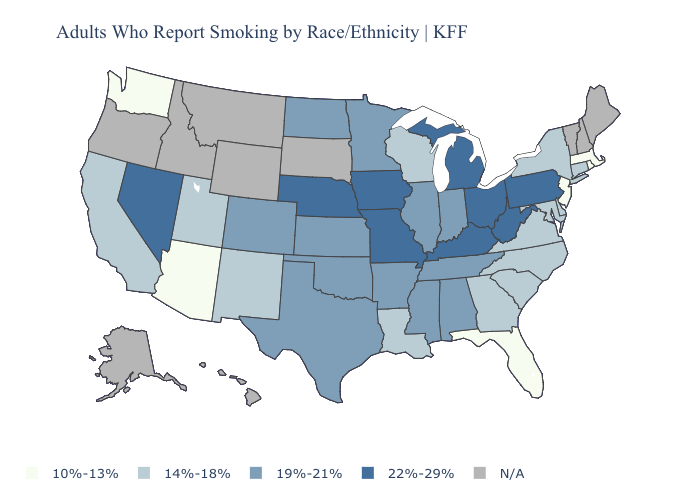Name the states that have a value in the range 10%-13%?
Give a very brief answer. Arizona, Florida, Massachusetts, New Jersey, Rhode Island, Washington. Name the states that have a value in the range N/A?
Quick response, please. Alaska, Hawaii, Idaho, Maine, Montana, New Hampshire, Oregon, South Dakota, Vermont, Wyoming. What is the lowest value in the USA?
Keep it brief. 10%-13%. What is the value of Utah?
Write a very short answer. 14%-18%. What is the value of California?
Quick response, please. 14%-18%. Does Virginia have the lowest value in the USA?
Give a very brief answer. No. How many symbols are there in the legend?
Be succinct. 5. What is the highest value in the West ?
Give a very brief answer. 22%-29%. Does the first symbol in the legend represent the smallest category?
Write a very short answer. Yes. What is the value of Kentucky?
Be succinct. 22%-29%. Name the states that have a value in the range N/A?
Be succinct. Alaska, Hawaii, Idaho, Maine, Montana, New Hampshire, Oregon, South Dakota, Vermont, Wyoming. Does Colorado have the lowest value in the USA?
Quick response, please. No. Name the states that have a value in the range 14%-18%?
Write a very short answer. California, Connecticut, Delaware, Georgia, Louisiana, Maryland, New Mexico, New York, North Carolina, South Carolina, Utah, Virginia, Wisconsin. 